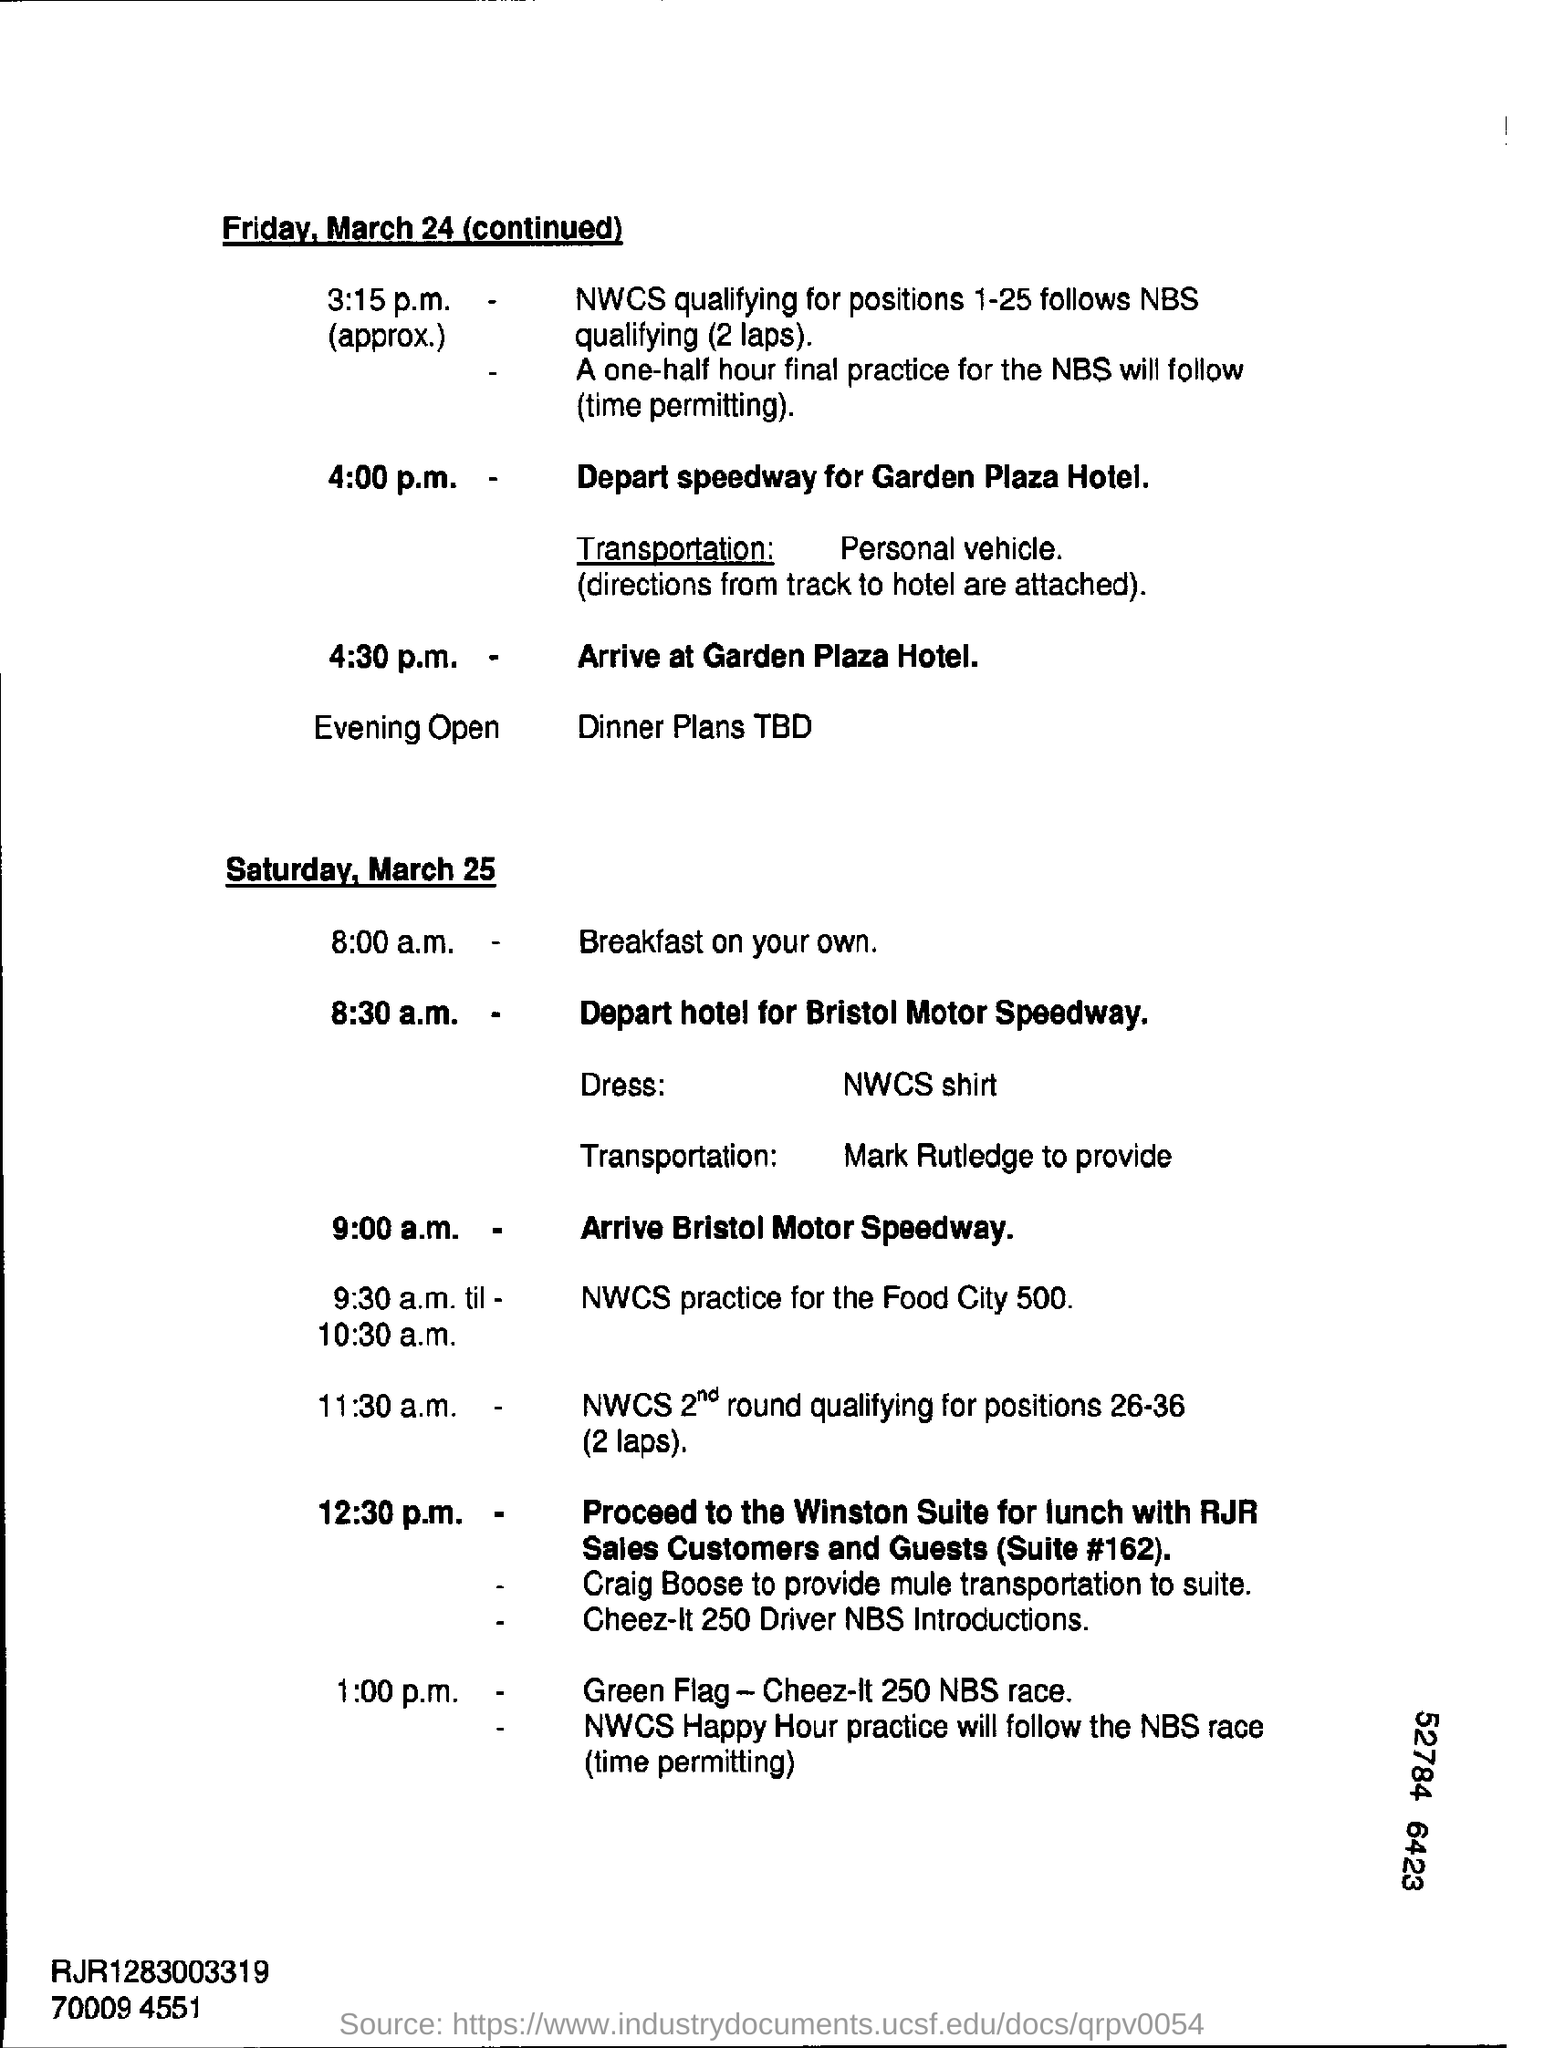What is the event at 4:00 p.m. on Friday, March 24?
Offer a terse response. Depart speedway for Garden Plaza Hotel. 